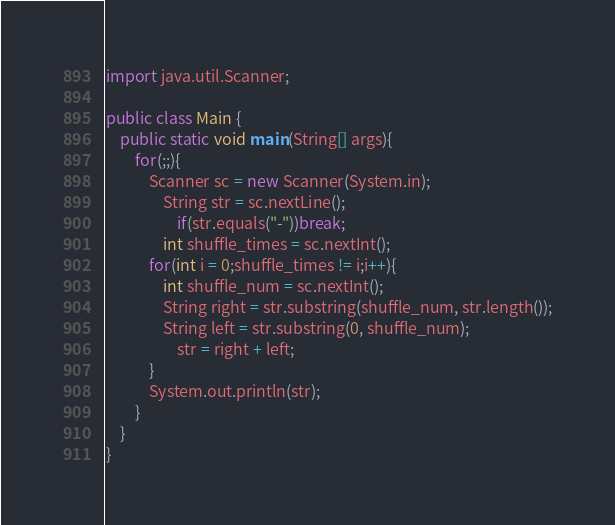<code> <loc_0><loc_0><loc_500><loc_500><_Java_>import java.util.Scanner;

public class Main {
	public static void main(String[] args){
		for(;;){
			Scanner sc = new Scanner(System.in);
				String str = sc.nextLine();
					if(str.equals("-"))break;
				int shuffle_times = sc.nextInt();
			for(int i = 0;shuffle_times != i;i++){
				int shuffle_num = sc.nextInt();
				String right = str.substring(shuffle_num, str.length());
				String left = str.substring(0, shuffle_num);
					str = right + left;
			}
			System.out.println(str);
		}
	}
}</code> 